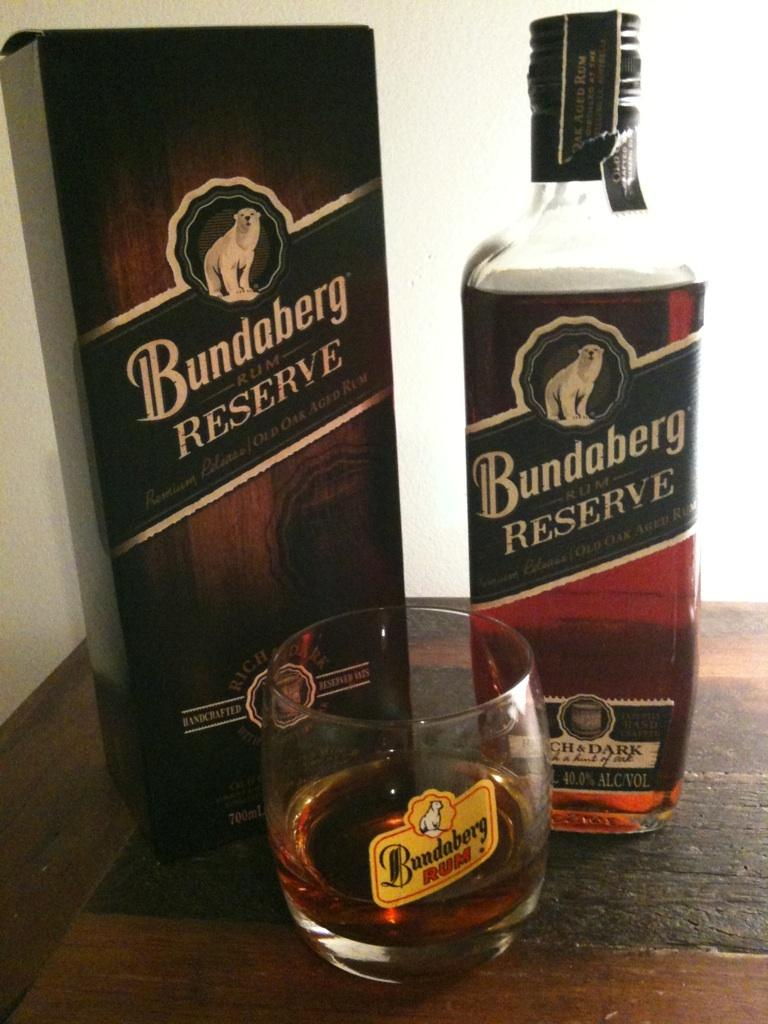What type of container is visible in the image? There is a bottle in the image. What other type of container can be seen in the image? There is a glass in the image. What is the third object visible in the image? There is a box in the image. What type of ring can be seen on the box in the image? There is no ring present on the box in the image. What does the box represent in terms of hope? The box does not represent hope in the image; it is simply an object. 